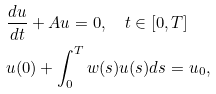Convert formula to latex. <formula><loc_0><loc_0><loc_500><loc_500>& \frac { d u } { d t } + A u = 0 , \quad t \in [ 0 , T ] \\ & u ( 0 ) + \int _ { 0 } ^ { T } w ( s ) u ( s ) d s = u _ { 0 } ,</formula> 